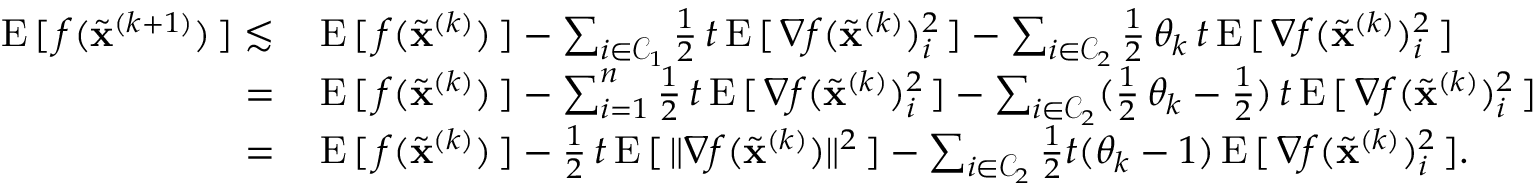Convert formula to latex. <formula><loc_0><loc_0><loc_500><loc_500>\begin{array} { r l } { E \, [ \, f ( \widetilde { x } ^ { ( k + 1 ) } ) \, ] \lesssim \, } & { E \, [ \, f ( \widetilde { x } ^ { ( k ) } ) \, ] - \sum _ { i \in { \mathcal { C } } _ { 1 } } \frac { 1 } { 2 } \, t \, E \, [ \, \nabla f ( \widetilde { x } ^ { ( k ) } ) _ { i } ^ { 2 } \, ] - \sum _ { i \in { \mathcal { C } } _ { 2 } } \frac { 1 } { 2 } \, \theta _ { k } \, t \, E \, [ \, \nabla f ( \widetilde { x } ^ { ( k ) } ) _ { i } ^ { 2 } \, ] } \\ { = \, } & { E \, [ \, f ( \widetilde { x } ^ { ( k ) } ) \, ] - \sum _ { i = 1 } ^ { n } \frac { 1 } { 2 } \, t \, E \, [ \, \nabla f ( \widetilde { x } ^ { ( k ) } ) _ { i } ^ { 2 } \, ] - \sum _ { i \in { \mathcal { C } } _ { 2 } } ( \frac { 1 } { 2 } \, \theta _ { k } - \frac { 1 } { 2 } ) \, t \, E \, [ \, \nabla f ( \widetilde { x } ^ { ( k ) } ) _ { i } ^ { 2 } \, ] } \\ { = \, } & { E \, [ \, f ( \widetilde { x } ^ { ( k ) } ) \, ] - \frac { 1 } { 2 } \, t \, E \, [ \, \| \nabla f ( \widetilde { x } ^ { ( k ) } ) \| ^ { 2 } \, ] - \sum _ { i \in { \mathcal { C } } _ { 2 } } \frac { 1 } { 2 } t ( \theta _ { k } - 1 ) \, E \, [ \, \nabla f ( \widetilde { x } ^ { ( k ) } ) _ { i } ^ { 2 } \, ] . } \end{array}</formula> 